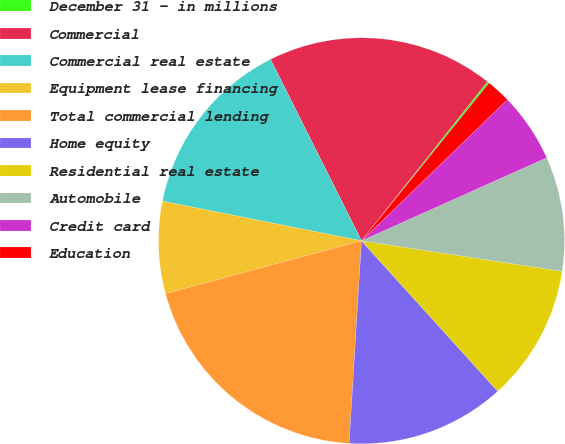<chart> <loc_0><loc_0><loc_500><loc_500><pie_chart><fcel>December 31 - in millions<fcel>Commercial<fcel>Commercial real estate<fcel>Equipment lease financing<fcel>Total commercial lending<fcel>Home equity<fcel>Residential real estate<fcel>Automobile<fcel>Credit card<fcel>Education<nl><fcel>0.16%<fcel>18.05%<fcel>14.47%<fcel>7.32%<fcel>19.84%<fcel>12.68%<fcel>10.89%<fcel>9.11%<fcel>5.53%<fcel>1.95%<nl></chart> 